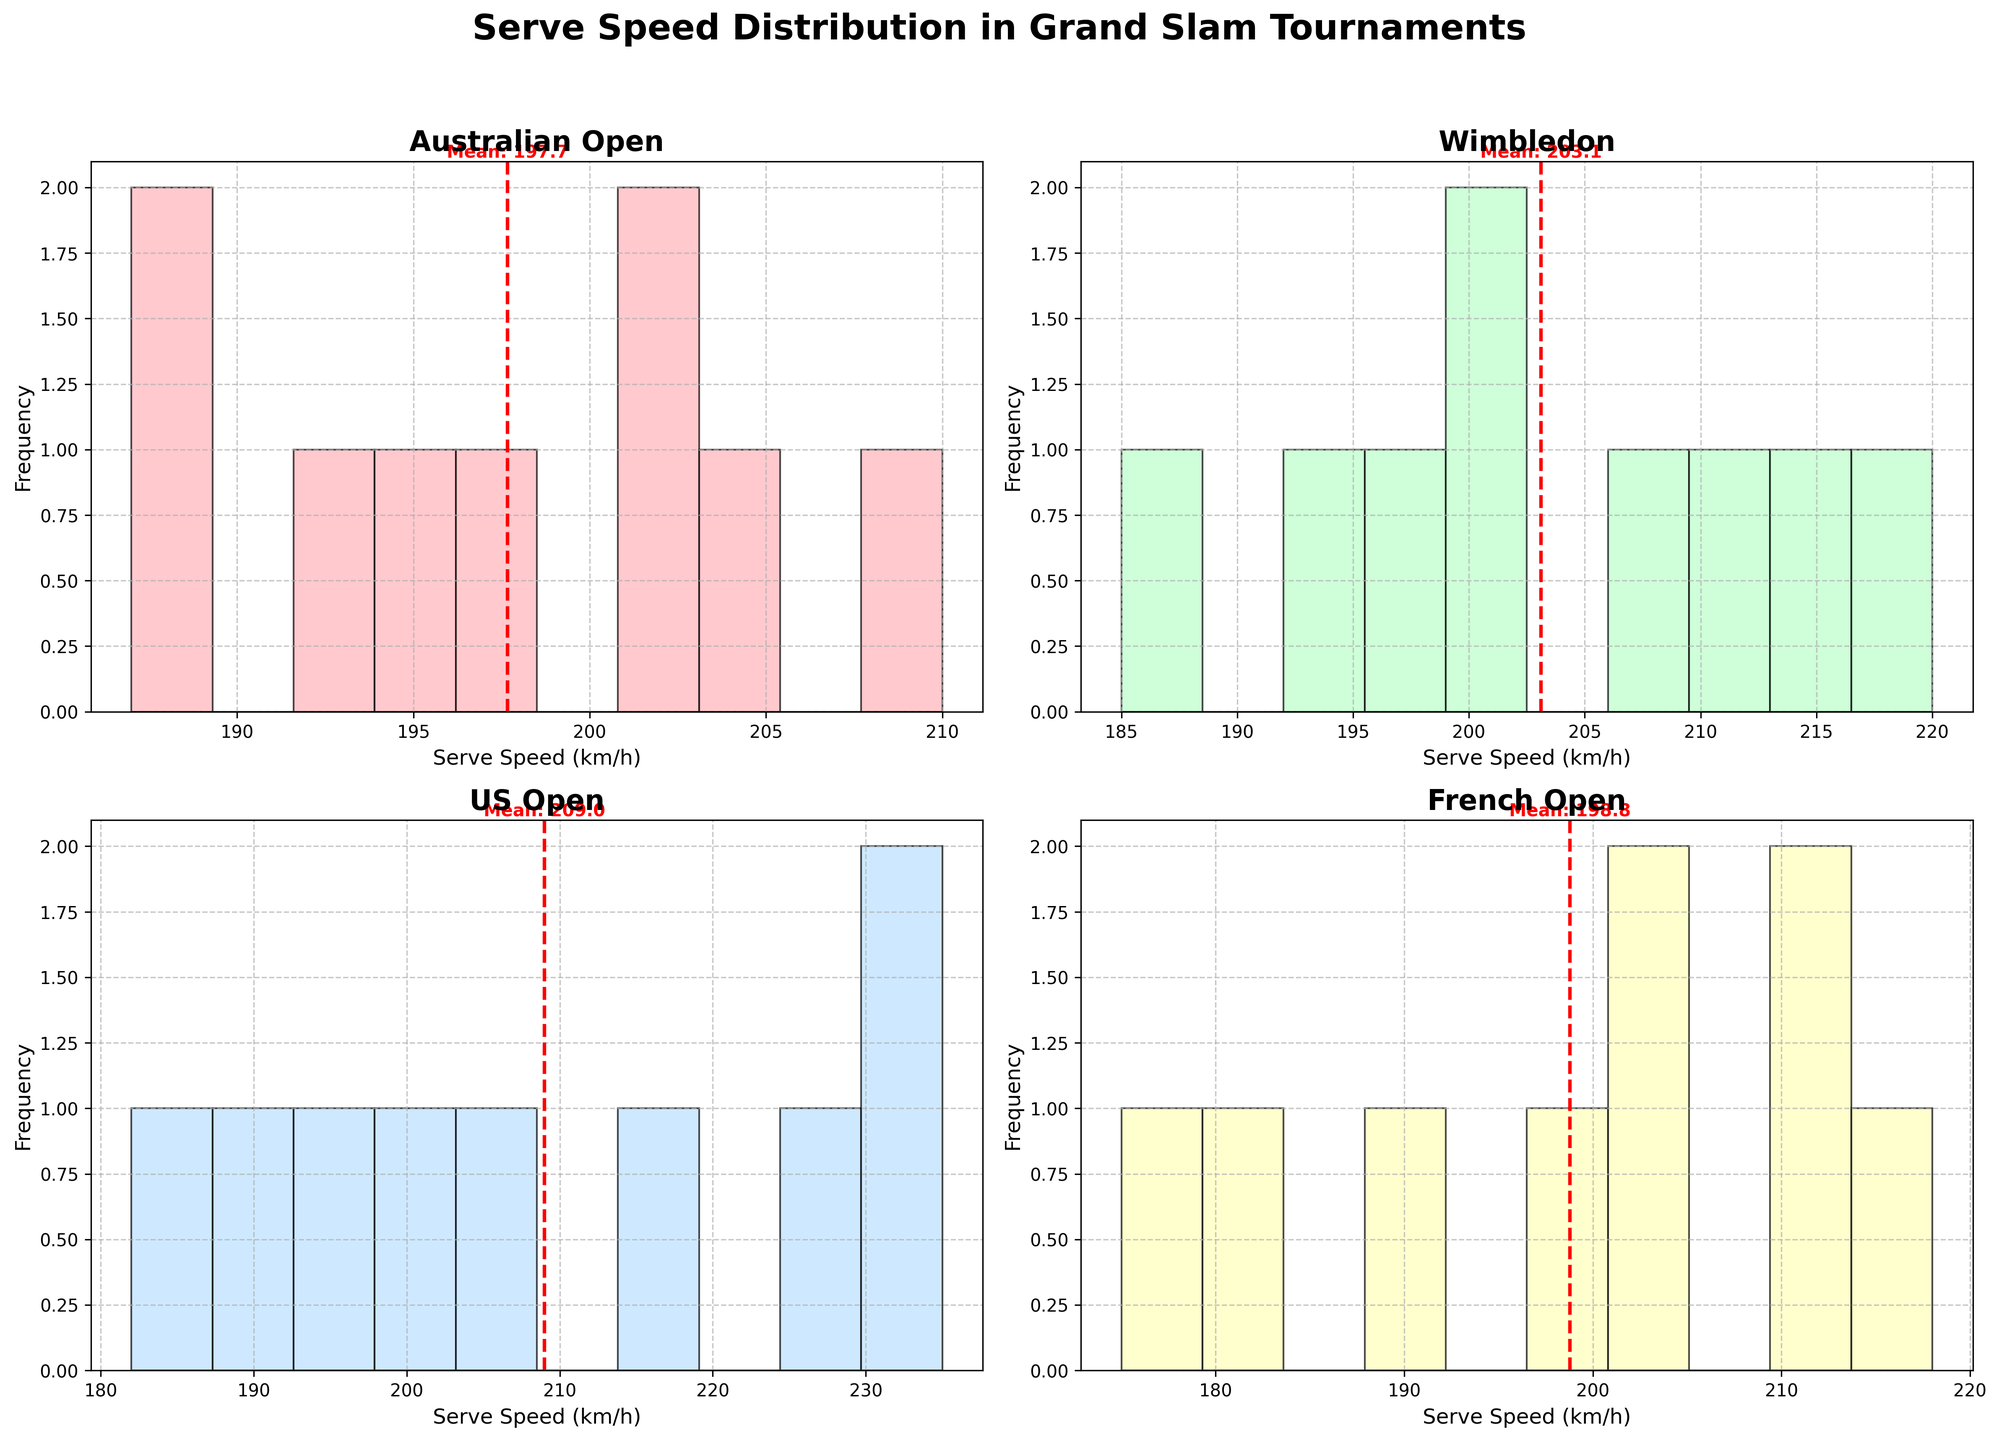What is the average serve speed at the Australian Open? The mean line in the Australian Open subplot indicates the average serve speed. The value shown near the dashed red line is the mean of the data points specific to the Australian Open.
Answer: 198.7 km/h Which Grand Slam tournament has the highest average serve speed? Compare the mean serve speeds indicated by the dashed red lines in each subplot. The subplot for the US Open shows the highest mean serve speed.
Answer: US Open What is the mean serve speed at Wimbledon? The mean line in the Wimbledon subplot shows the average serve speed, indicated by a red dashed line.
Answer: 202.3 km/h How does the mean serve speed at the French Open compare to the Australian Open? Compare the mean serve speed values from the French Open (195.4 km/h) and the Australian Open (198.7 km/h) subplots.
Answer: French Open mean is lower Which Grand Slam tournament has the lowest serve speed frequency distribution? Observe the height of the bars in each histogram. The French Open subplot has bars distributed over a lower range of serve speeds and has fewer high-frequency bars.
Answer: French Open What is the range of serve speeds at the US Open? Identify the minimum and maximum serve speeds visible in the histogram for the US Open subplot, which ranges from around 180 km/h to 235 km/h.
Answer: 180-235 km/h Which tournament exhibits the widest spread in serve speeds? Look for the tournament with the widest range of serve speeds (the distance between the lowest and highest values). The US Open has a spread from approximately 180 km/h to 235 km/h.
Answer: US Open Are there any outliers in the serve speed at the US Open? Checking for outliers by visual inspection of bars significantly apart from the rest. The US Open histogram shows a higher serve speed of 235 km/h, which can be considered an outlier.
Answer: Yes Which player has the highest recorded serve speed, and at which tournament? Identify the serve speed value of 235 km/h in the US Open histogram, which is John Isner's serve speed.
Answer: John Isner, US Open How does the frequency distribution of serve speeds at Wimbledon differ from the French Open? Compare the histograms: Wimbledon has more frequent higher serve speeds (above 200 km/h) whereas the French Open has more moderate serve speed values.
Answer: Wimbledon has higher frequencies of faster serves 